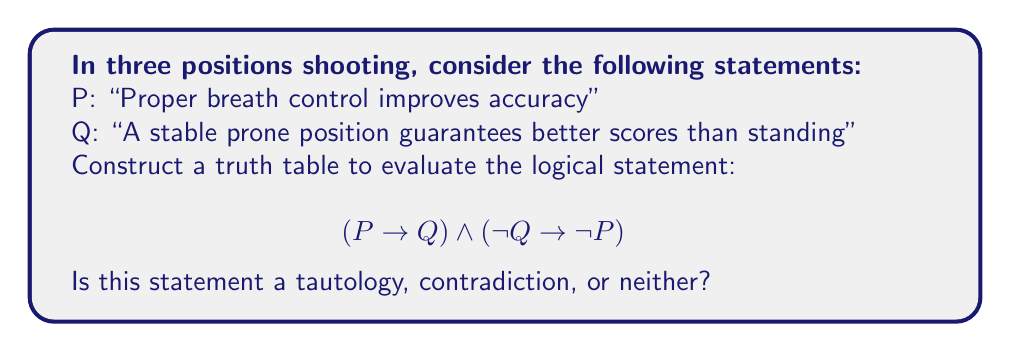Can you solve this math problem? To evaluate the validity of this statement, we'll construct a truth table and analyze the results:

1. First, let's identify our atomic propositions:
   P: "Proper breath control improves accuracy"
   Q: "A stable prone position guarantees better scores than standing"

2. Now, we'll create a truth table with columns for P, Q, and the compound statement:

   | P | Q | P → Q | ¬Q | ¬P | ¬Q → ¬P | (P → Q) ∧ (¬Q → ¬P) |
   |---|---|-------|----|----|---------|----------------------|
   | T | T |   T   | F  | F  |    T    |          T           |
   | T | F |   F   | T  | F  |    F    |          F           |
   | F | T |   T   | F  | T  |    T    |          T           |
   | F | F |   T   | T  | T  |    T    |          T           |

3. Let's break down each column:
   - P → Q: This is true except when P is true and Q is false.
   - ¬Q: This is the negation of Q.
   - ¬P: This is the negation of P.
   - ¬Q → ¬P: This is true except when ¬Q is true and ¬P is false.
   - (P → Q) ∧ (¬Q → ¬P): This is the conjunction of the two implications.

4. Analyzing the final column:
   - The statement is true in 3 out of 4 cases.
   - It's false only when P is true and Q is false.

5. Since the statement is not true for all possible combinations of P and Q, it is neither a tautology nor a contradiction.

In the context of three positions shooting:
- The statement is false in the scenario where proper breath control does improve accuracy (P is true), but a stable prone position doesn't guarantee better scores than standing (Q is false). This could occur in situations where other factors, such as wind conditions or shooter fatigue, play a significant role in the standing position performance.
Answer: Neither a tautology nor a contradiction 